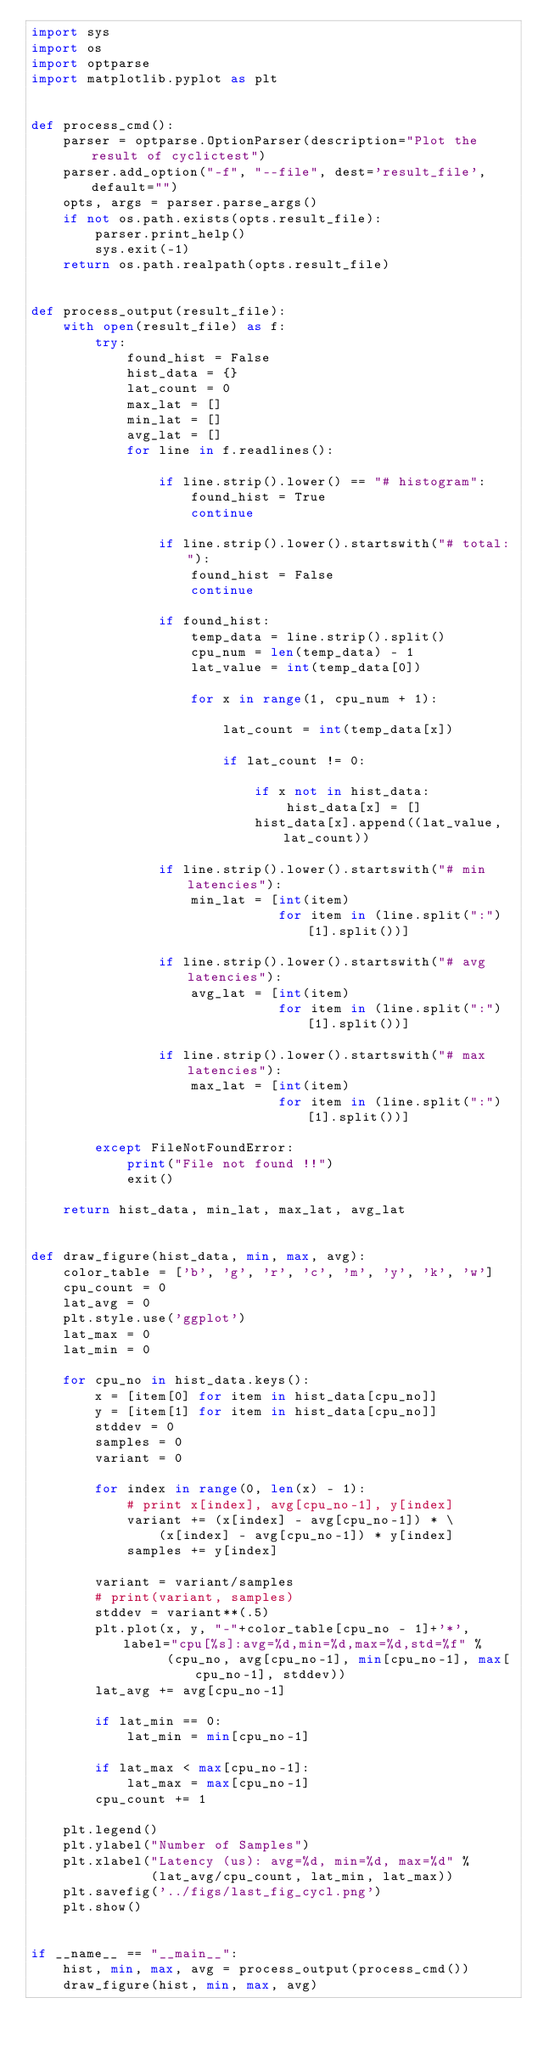Convert code to text. <code><loc_0><loc_0><loc_500><loc_500><_Python_>import sys
import os
import optparse
import matplotlib.pyplot as plt


def process_cmd():
    parser = optparse.OptionParser(description="Plot the result of cyclictest")
    parser.add_option("-f", "--file", dest='result_file', default="")
    opts, args = parser.parse_args()
    if not os.path.exists(opts.result_file):
        parser.print_help()
        sys.exit(-1)
    return os.path.realpath(opts.result_file)


def process_output(result_file):
    with open(result_file) as f:
        try:
            found_hist = False
            hist_data = {}
            lat_count = 0
            max_lat = []
            min_lat = []
            avg_lat = []
            for line in f.readlines():

                if line.strip().lower() == "# histogram":
                    found_hist = True
                    continue

                if line.strip().lower().startswith("# total:"):
                    found_hist = False
                    continue

                if found_hist:
                    temp_data = line.strip().split()
                    cpu_num = len(temp_data) - 1
                    lat_value = int(temp_data[0])

                    for x in range(1, cpu_num + 1):

                        lat_count = int(temp_data[x])

                        if lat_count != 0:

                            if x not in hist_data:
                                hist_data[x] = []
                            hist_data[x].append((lat_value, lat_count))

                if line.strip().lower().startswith("# min latencies"):
                    min_lat = [int(item)
                               for item in (line.split(":")[1].split())]

                if line.strip().lower().startswith("# avg latencies"):
                    avg_lat = [int(item)
                               for item in (line.split(":")[1].split())]

                if line.strip().lower().startswith("# max latencies"):
                    max_lat = [int(item)
                               for item in (line.split(":")[1].split())]

        except FileNotFoundError:
            print("File not found !!")
            exit()

    return hist_data, min_lat, max_lat, avg_lat


def draw_figure(hist_data, min, max, avg):
    color_table = ['b', 'g', 'r', 'c', 'm', 'y', 'k', 'w']
    cpu_count = 0
    lat_avg = 0
    plt.style.use('ggplot')
    lat_max = 0
    lat_min = 0

    for cpu_no in hist_data.keys():
        x = [item[0] for item in hist_data[cpu_no]]
        y = [item[1] for item in hist_data[cpu_no]]
        stddev = 0
        samples = 0
        variant = 0

        for index in range(0, len(x) - 1):
            # print x[index], avg[cpu_no-1], y[index]
            variant += (x[index] - avg[cpu_no-1]) * \
                (x[index] - avg[cpu_no-1]) * y[index]
            samples += y[index]

        variant = variant/samples
        # print(variant, samples)
        stddev = variant**(.5)
        plt.plot(x, y, "-"+color_table[cpu_no - 1]+'*', label="cpu[%s]:avg=%d,min=%d,max=%d,std=%f" %
                 (cpu_no, avg[cpu_no-1], min[cpu_no-1], max[cpu_no-1], stddev))
        lat_avg += avg[cpu_no-1]

        if lat_min == 0:
            lat_min = min[cpu_no-1]

        if lat_max < max[cpu_no-1]:
            lat_max = max[cpu_no-1]
        cpu_count += 1

    plt.legend()
    plt.ylabel("Number of Samples")
    plt.xlabel("Latency (us): avg=%d, min=%d, max=%d" %
               (lat_avg/cpu_count, lat_min, lat_max))
    plt.savefig('../figs/last_fig_cycl.png')
    plt.show()


if __name__ == "__main__":
    hist, min, max, avg = process_output(process_cmd())
    draw_figure(hist, min, max, avg)
</code> 